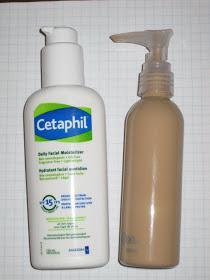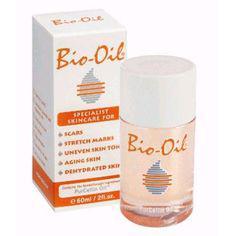The first image is the image on the left, the second image is the image on the right. Assess this claim about the two images: "An image includes multiple clear containers filled with white and brown substances.". Correct or not? Answer yes or no. No. The first image is the image on the left, the second image is the image on the right. For the images displayed, is the sentence "Powder sits in a glass bowl in one of the images." factually correct? Answer yes or no. No. 